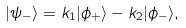Convert formula to latex. <formula><loc_0><loc_0><loc_500><loc_500>| \psi _ { - } \rangle = k _ { 1 } | \phi _ { + } \rangle - k _ { 2 } | \phi _ { - } \rangle ,</formula> 